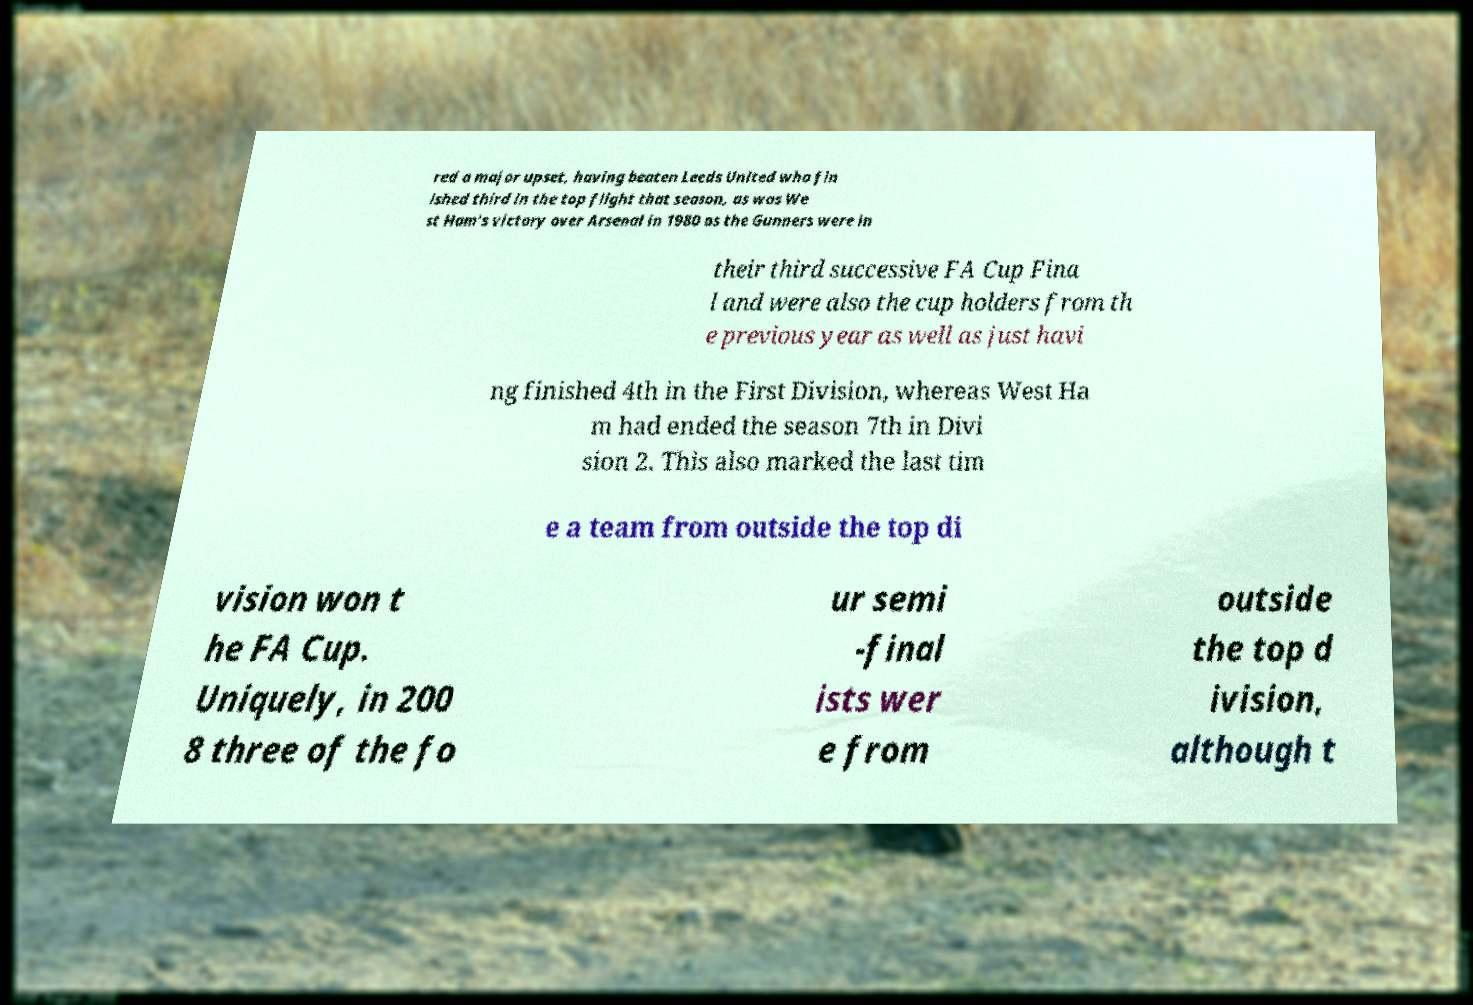Please read and relay the text visible in this image. What does it say? red a major upset, having beaten Leeds United who fin ished third in the top flight that season, as was We st Ham's victory over Arsenal in 1980 as the Gunners were in their third successive FA Cup Fina l and were also the cup holders from th e previous year as well as just havi ng finished 4th in the First Division, whereas West Ha m had ended the season 7th in Divi sion 2. This also marked the last tim e a team from outside the top di vision won t he FA Cup. Uniquely, in 200 8 three of the fo ur semi -final ists wer e from outside the top d ivision, although t 